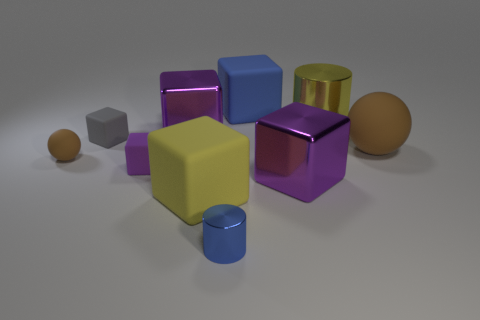Can you tell me what the scene depicts? The scene appears to be a collection of various geometric shapes that are likely used for illustration or educational purposes to teach about colors, geometry, and spatial awareness. Are all the objects similar in texture? Not quite. The objects have different appearances: while most have a shiny, smooth texture suggestive of a reflective material, there might be subtle differences in material properties that aren't visibly discernable. 